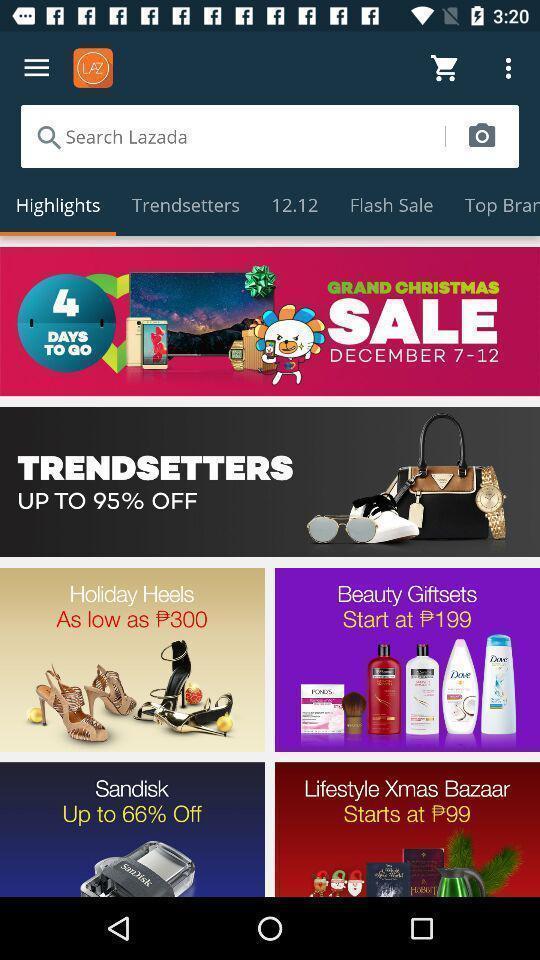Describe the content in this image. Search bar to search for the items listed. 